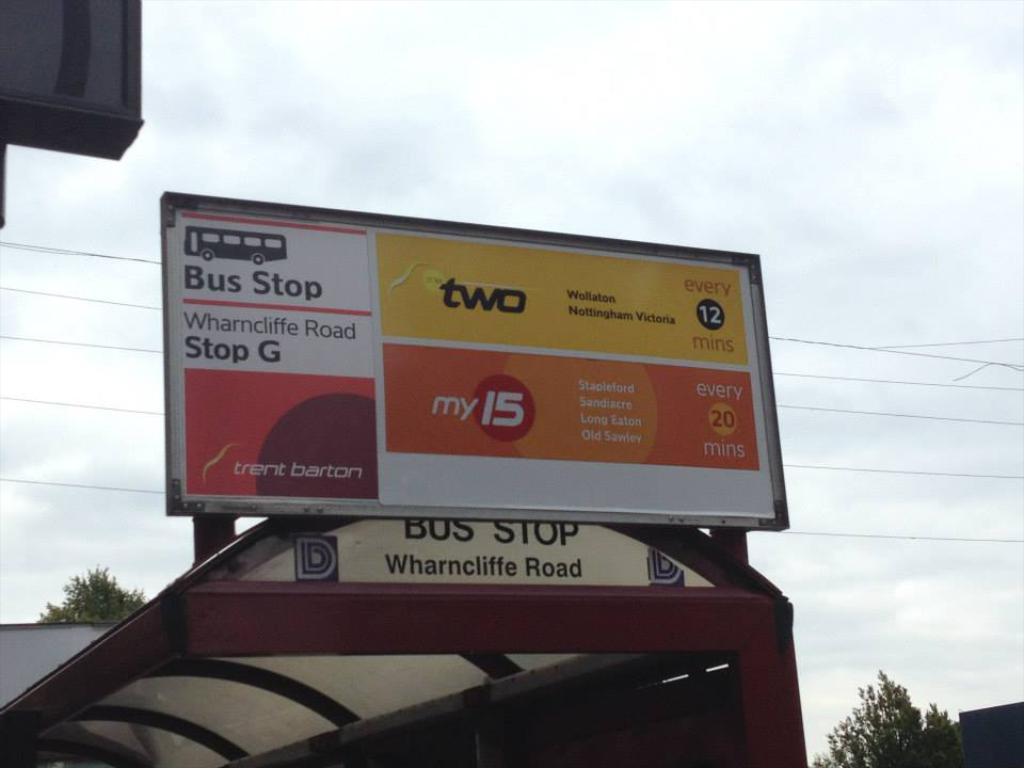<image>
Relay a brief, clear account of the picture shown. a Bus Stop for Wharncliffe Road is under a cloudy sky 